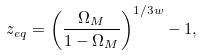Convert formula to latex. <formula><loc_0><loc_0><loc_500><loc_500>z _ { e q } = \left ( \frac { \Omega _ { M } } { 1 - \Omega _ { M } } \right ) ^ { 1 / 3 w } - 1 ,</formula> 